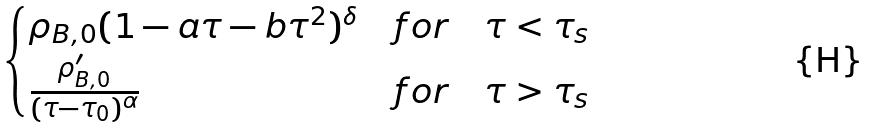Convert formula to latex. <formula><loc_0><loc_0><loc_500><loc_500>\begin{cases} \rho _ { B , 0 } ( 1 - a \tau - b \tau ^ { 2 } ) ^ { \delta } & f o r \quad \tau < \tau _ { s } \\ \frac { \rho _ { B , 0 } ^ { \prime } } { ( \tau - \tau _ { 0 } ) ^ { \alpha } } & f o r \quad \tau > \tau _ { s } \end{cases}</formula> 